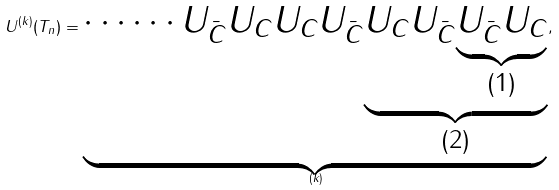<formula> <loc_0><loc_0><loc_500><loc_500>U ^ { ( k ) } ( T _ { n } ) = \underbrace { \cdots \cdots U _ { \bar { C } } U _ { C } U _ { C } U _ { \bar { C } } { \underbrace { U _ { C } U _ { \bar { C } } { \underbrace { U _ { \bar { C } } U _ { C } } _ { ( 1 ) } } } _ { ( 2 ) } } } _ { ( k ) } ,</formula> 